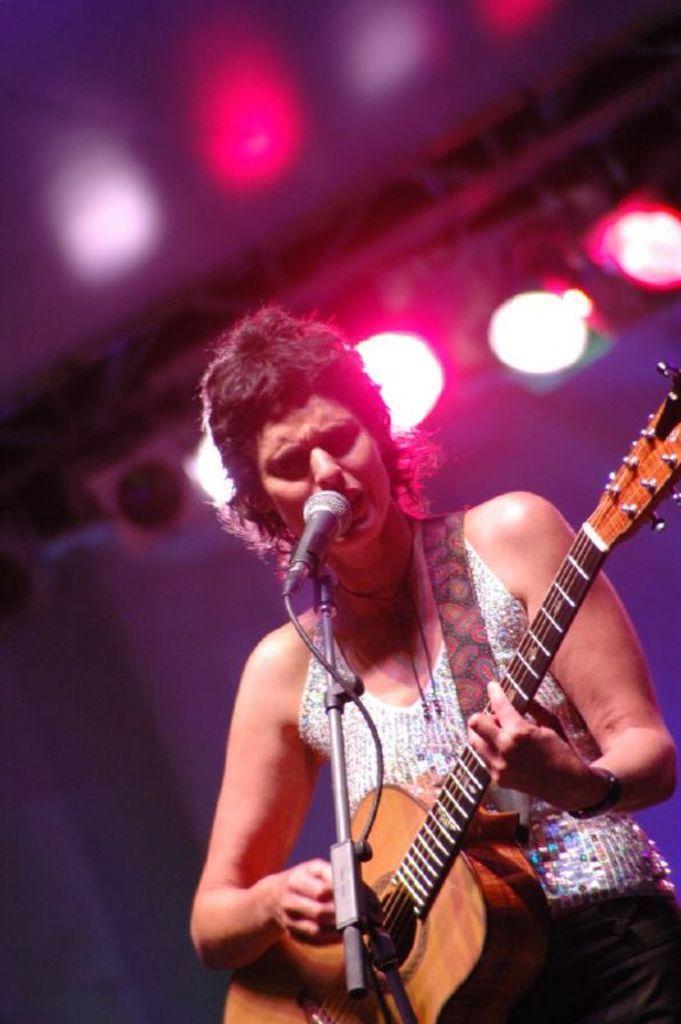Could you give a brief overview of what you see in this image? In this image I see a person who is holding a guitar and is in front of a mic. In the background I see the lights. 